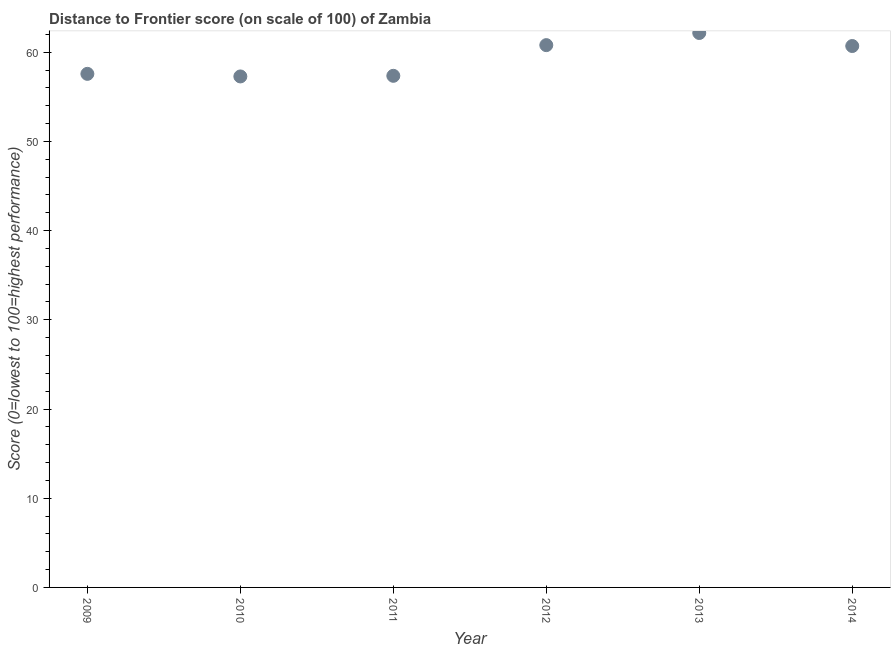What is the distance to frontier score in 2010?
Offer a terse response. 57.28. Across all years, what is the maximum distance to frontier score?
Your response must be concise. 62.15. Across all years, what is the minimum distance to frontier score?
Keep it short and to the point. 57.28. In which year was the distance to frontier score maximum?
Offer a very short reply. 2013. In which year was the distance to frontier score minimum?
Offer a very short reply. 2010. What is the sum of the distance to frontier score?
Make the answer very short. 355.83. What is the difference between the distance to frontier score in 2010 and 2014?
Make the answer very short. -3.41. What is the average distance to frontier score per year?
Provide a short and direct response. 59.3. What is the median distance to frontier score?
Your answer should be compact. 59.13. In how many years, is the distance to frontier score greater than 22 ?
Make the answer very short. 6. Do a majority of the years between 2009 and 2014 (inclusive) have distance to frontier score greater than 58 ?
Offer a very short reply. No. What is the ratio of the distance to frontier score in 2009 to that in 2013?
Your answer should be very brief. 0.93. Is the difference between the distance to frontier score in 2010 and 2012 greater than the difference between any two years?
Make the answer very short. No. What is the difference between the highest and the second highest distance to frontier score?
Ensure brevity in your answer.  1.36. What is the difference between the highest and the lowest distance to frontier score?
Give a very brief answer. 4.87. Does the distance to frontier score monotonically increase over the years?
Offer a terse response. No. Are the values on the major ticks of Y-axis written in scientific E-notation?
Keep it short and to the point. No. Does the graph contain any zero values?
Provide a short and direct response. No. What is the title of the graph?
Provide a succinct answer. Distance to Frontier score (on scale of 100) of Zambia. What is the label or title of the Y-axis?
Keep it short and to the point. Score (0=lowest to 100=highest performance). What is the Score (0=lowest to 100=highest performance) in 2009?
Offer a very short reply. 57.57. What is the Score (0=lowest to 100=highest performance) in 2010?
Provide a short and direct response. 57.28. What is the Score (0=lowest to 100=highest performance) in 2011?
Provide a short and direct response. 57.35. What is the Score (0=lowest to 100=highest performance) in 2012?
Provide a short and direct response. 60.79. What is the Score (0=lowest to 100=highest performance) in 2013?
Your answer should be very brief. 62.15. What is the Score (0=lowest to 100=highest performance) in 2014?
Give a very brief answer. 60.69. What is the difference between the Score (0=lowest to 100=highest performance) in 2009 and 2010?
Ensure brevity in your answer.  0.29. What is the difference between the Score (0=lowest to 100=highest performance) in 2009 and 2011?
Your response must be concise. 0.22. What is the difference between the Score (0=lowest to 100=highest performance) in 2009 and 2012?
Provide a short and direct response. -3.22. What is the difference between the Score (0=lowest to 100=highest performance) in 2009 and 2013?
Your answer should be very brief. -4.58. What is the difference between the Score (0=lowest to 100=highest performance) in 2009 and 2014?
Your answer should be compact. -3.12. What is the difference between the Score (0=lowest to 100=highest performance) in 2010 and 2011?
Ensure brevity in your answer.  -0.07. What is the difference between the Score (0=lowest to 100=highest performance) in 2010 and 2012?
Your response must be concise. -3.51. What is the difference between the Score (0=lowest to 100=highest performance) in 2010 and 2013?
Provide a succinct answer. -4.87. What is the difference between the Score (0=lowest to 100=highest performance) in 2010 and 2014?
Offer a very short reply. -3.41. What is the difference between the Score (0=lowest to 100=highest performance) in 2011 and 2012?
Provide a succinct answer. -3.44. What is the difference between the Score (0=lowest to 100=highest performance) in 2011 and 2013?
Ensure brevity in your answer.  -4.8. What is the difference between the Score (0=lowest to 100=highest performance) in 2011 and 2014?
Your answer should be very brief. -3.34. What is the difference between the Score (0=lowest to 100=highest performance) in 2012 and 2013?
Make the answer very short. -1.36. What is the difference between the Score (0=lowest to 100=highest performance) in 2013 and 2014?
Your answer should be very brief. 1.46. What is the ratio of the Score (0=lowest to 100=highest performance) in 2009 to that in 2010?
Make the answer very short. 1. What is the ratio of the Score (0=lowest to 100=highest performance) in 2009 to that in 2012?
Offer a terse response. 0.95. What is the ratio of the Score (0=lowest to 100=highest performance) in 2009 to that in 2013?
Keep it short and to the point. 0.93. What is the ratio of the Score (0=lowest to 100=highest performance) in 2009 to that in 2014?
Offer a terse response. 0.95. What is the ratio of the Score (0=lowest to 100=highest performance) in 2010 to that in 2011?
Ensure brevity in your answer.  1. What is the ratio of the Score (0=lowest to 100=highest performance) in 2010 to that in 2012?
Offer a terse response. 0.94. What is the ratio of the Score (0=lowest to 100=highest performance) in 2010 to that in 2013?
Make the answer very short. 0.92. What is the ratio of the Score (0=lowest to 100=highest performance) in 2010 to that in 2014?
Offer a very short reply. 0.94. What is the ratio of the Score (0=lowest to 100=highest performance) in 2011 to that in 2012?
Keep it short and to the point. 0.94. What is the ratio of the Score (0=lowest to 100=highest performance) in 2011 to that in 2013?
Ensure brevity in your answer.  0.92. What is the ratio of the Score (0=lowest to 100=highest performance) in 2011 to that in 2014?
Your answer should be very brief. 0.94. What is the ratio of the Score (0=lowest to 100=highest performance) in 2012 to that in 2013?
Provide a short and direct response. 0.98. What is the ratio of the Score (0=lowest to 100=highest performance) in 2012 to that in 2014?
Keep it short and to the point. 1. 